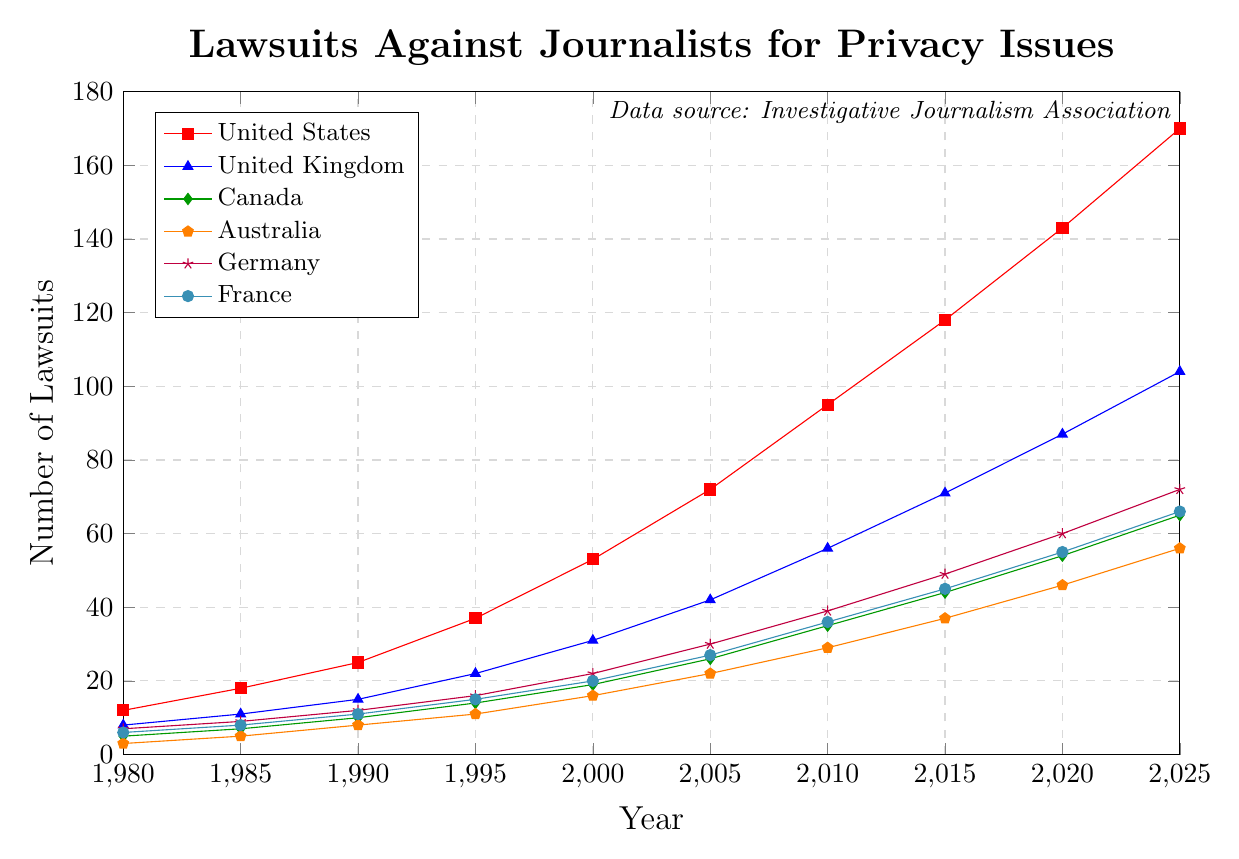What's the trend in the number of lawsuits in the United States from 1980 to 2025? To determine the trend, look at how the values for the United States change over the years. The number of lawsuits increases each year, starting from 12 in 1980 and reaching 170 by 2025.
Answer: Increasing Which country had the highest number of lawsuits in 2025? Compare the number of lawsuits for each country in the year 2025. The United States has the highest number with 170 lawsuits.
Answer: United States What was the total number of lawsuits filed across all countries in 2000? Sum the values for all countries in the year 2000: 53 (US) + 31 (UK) + 19 (Canada) + 16 (Australia) + 22 (Germany) + 20 (France) = 161.
Answer: 161 Between 1985 and 1995, which country experienced the greatest increase in the number of lawsuits? Calculate the difference for each country between 1995 and 1985, then identify the maximum value. 
US: 37-18=19, 
UK: 22-11=11, 
Canada: 14-7=7,
Australia: 11-5=6,
Germany: 16-9=7, 
France: 15-8=7. The United States had the greatest increase with 19 lawsuits.
Answer: United States By how much did the number of lawsuits in Germany change from 2005 to 2020? Subtract the number of lawsuits in 2005 from the number in 2020 for Germany: 60 - 30 = 30.
Answer: 30 What was the average number of lawsuits in Canada in the years 1990, 2000, and 2010? Sum the number of lawsuits in Canada for these years and divide by 3: (10 + 19 + 35) / 3 = 21.33.
Answer: 21.33 Did any country have fewer than 10 lawsuits in 1990? Inspect the data for each country in the year 1990. Canada and Australia had fewer than 10 lawsuits, with 10 and 8 respectively.
Answer: Yes How many years saw more than 50 lawsuits in the United Kingdom? Count the number of years where the number of lawsuits in the UK exceeds 50. These years are 2010, 2015, 2020, and 2025 (thus 4 years in total).
Answer: 4 In which year did Australia first exceed 20 lawsuits? Identify the first year where the number of lawsuits in Australia is greater than 20. This occurred in 2005 with 22 lawsuits.
Answer: 2005 Among all countries, which one had the smallest increase in the number of lawsuits between 1980 and 2025? Calculate the increase for each country from 1980 to 2025, then find the minimum value.
US: 170-12=158,
UK: 104-8=96,
Canada: 65-5=60,
Australia: 56-3=53,
Germany: 72-7=65,
France: 66-6=60. Australia had the smallest increase, with 53 lawsuits.
Answer: Australia 